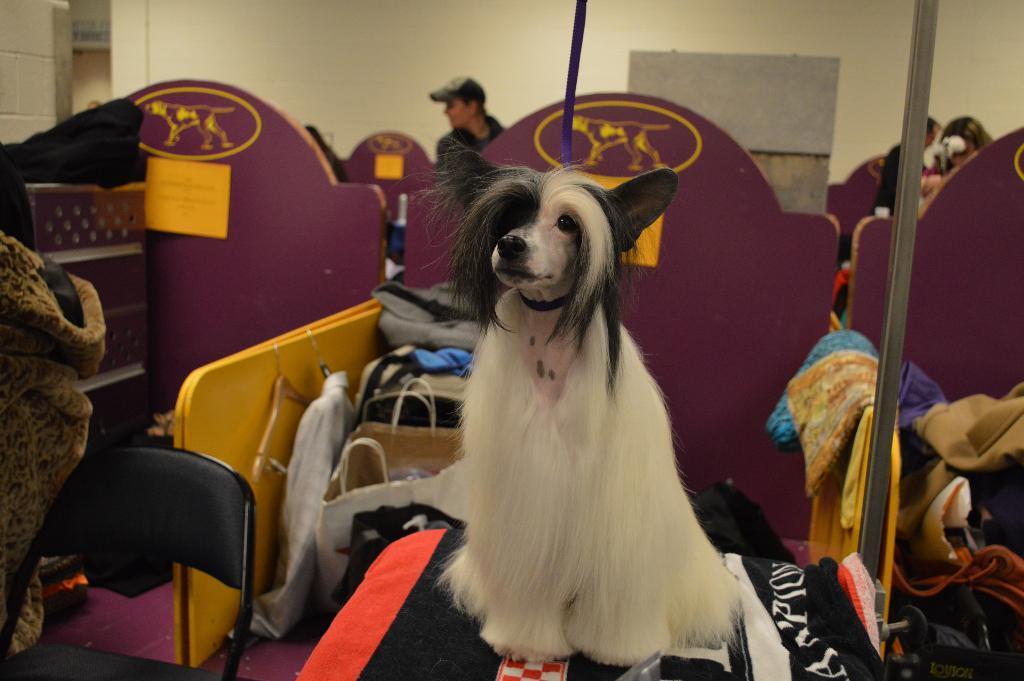Could you give a brief overview of what you see in this image? In this picture we can observe a dog. The dog is in white and black color. We can observe a black color chair on the left side. We can observe a pole here. In the background there are some people standing. There is a purple color railing here. In the background there is a wall. 